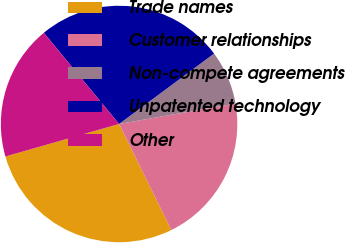Convert chart to OTSL. <chart><loc_0><loc_0><loc_500><loc_500><pie_chart><fcel>Trade names<fcel>Customer relationships<fcel>Non-compete agreements<fcel>Unpatented technology<fcel>Other<nl><fcel>27.86%<fcel>20.48%<fcel>7.38%<fcel>25.83%<fcel>18.45%<nl></chart> 